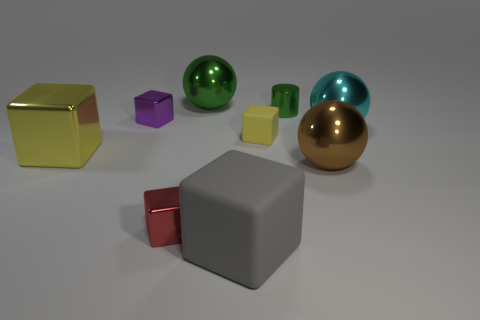Are there more small things that are on the left side of the big metallic block than tiny things in front of the brown metal object?
Ensure brevity in your answer.  No. What number of other objects are the same size as the brown object?
Your response must be concise. 4. There is a large metallic ball that is in front of the large yellow block; is its color the same as the large matte block?
Keep it short and to the point. No. Is the number of balls in front of the big rubber block greater than the number of shiny blocks?
Offer a terse response. No. Is there any other thing that has the same color as the metallic cylinder?
Your answer should be very brief. Yes. There is a small shiny object that is on the right side of the tiny red object in front of the large yellow metallic cube; what shape is it?
Keep it short and to the point. Cylinder. Are there more big yellow blocks than cubes?
Your response must be concise. No. How many yellow objects are to the left of the gray matte thing and to the right of the red block?
Provide a succinct answer. 0. There is a metallic thing that is right of the large brown ball; what number of tiny metal blocks are behind it?
Offer a terse response. 1. How many things are either large shiny spheres that are to the left of the cylinder or things in front of the big green object?
Offer a very short reply. 9. 